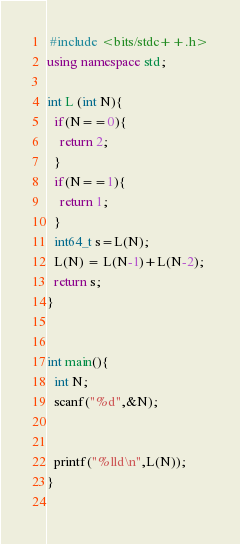Convert code to text. <code><loc_0><loc_0><loc_500><loc_500><_C++_> #include <bits/stdc++.h>
using namespace std;

int L (int N){
  if(N==0){
    return 2;
  }
  if(N==1){
    return 1;
  }
  int64_t s=L(N);
  L(N) = L(N-1)+L(N-2);
  return s;
}
    
  
int main(){
  int N;
  scanf("%d",&N);

  
  printf("%lld\n",L(N));
}
 

</code> 